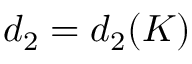<formula> <loc_0><loc_0><loc_500><loc_500>d _ { 2 } = d _ { 2 } ( K )</formula> 